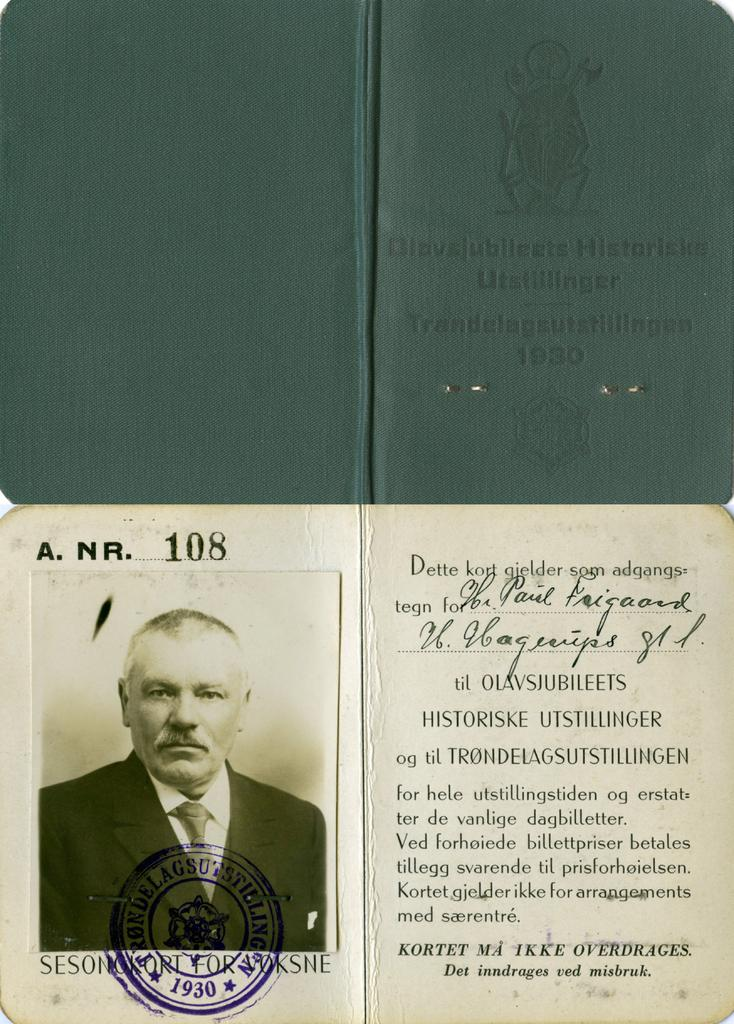What object is present in the image that is commonly used for identification purposes? The image contains an identification card. To whom does the identification card belong? The identification card belongs to a person. What type of lamp is visible in the image? There is no lamp present in the image. What type of vegetable is being used as a decoration in the image? There is no vegetable, such as celery, present in the image. What type of toy is being played with in the image? There is no toy present in the image. 